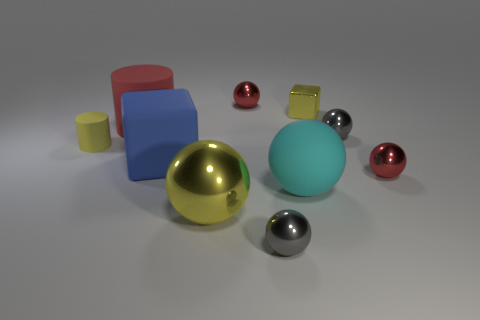How many big blue objects have the same material as the cyan sphere?
Provide a short and direct response. 1. There is a red metal ball that is behind the tiny red metal thing that is in front of the tiny yellow shiny thing; what is its size?
Ensure brevity in your answer.  Small. What color is the small metallic ball that is in front of the yellow block and to the left of the tiny yellow block?
Provide a short and direct response. Gray. Does the red matte thing have the same shape as the tiny yellow matte thing?
Your answer should be compact. Yes. The metallic sphere that is the same color as the tiny matte thing is what size?
Give a very brief answer. Large. There is a red object right of the tiny gray ball in front of the blue rubber thing; what is its shape?
Provide a short and direct response. Sphere. There is a tiny yellow shiny thing; does it have the same shape as the yellow shiny thing left of the big matte ball?
Provide a short and direct response. No. The cube that is the same size as the cyan rubber thing is what color?
Keep it short and to the point. Blue. Is the number of gray metallic things that are on the left side of the big matte sphere less than the number of balls in front of the large cube?
Your answer should be compact. Yes. There is a yellow metal object that is in front of the gray object that is behind the red object that is right of the cyan sphere; what is its shape?
Provide a succinct answer. Sphere. 